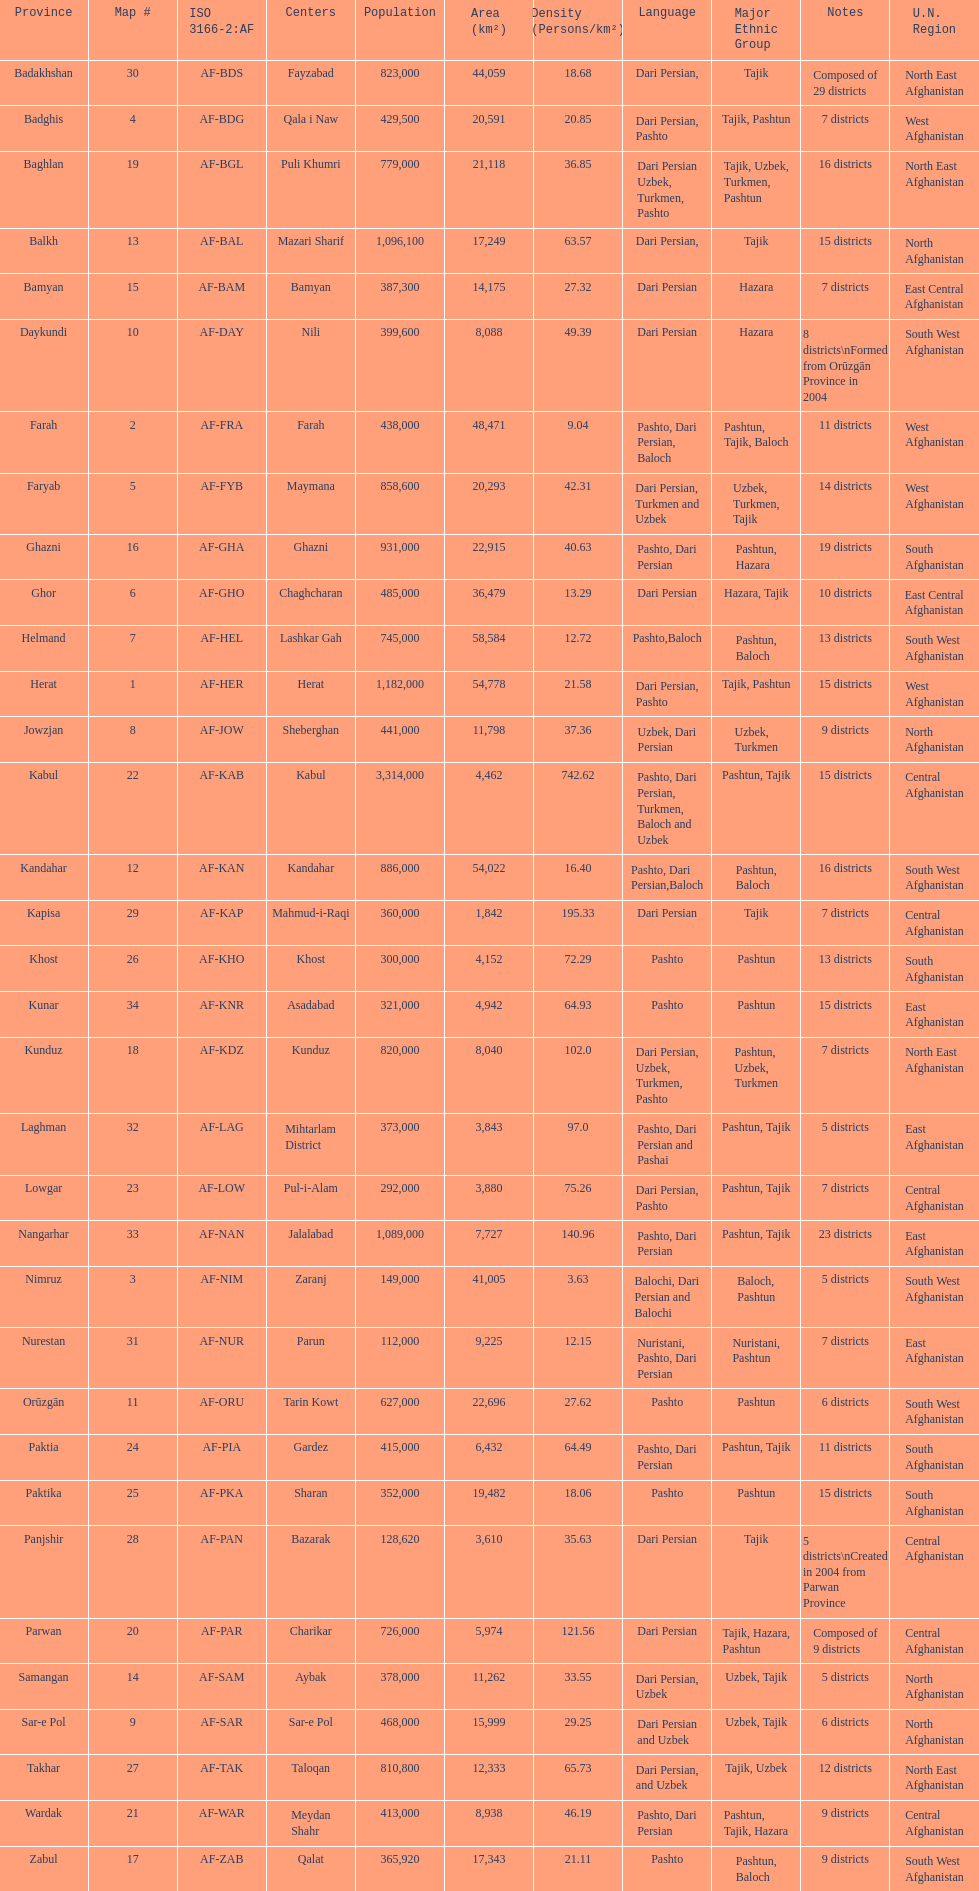Herat has a population of 1,182,000, can you list their languages Dari Persian, Pashto. I'm looking to parse the entire table for insights. Could you assist me with that? {'header': ['Province', 'Map #', 'ISO 3166-2:AF', 'Centers', 'Population', 'Area (km²)', 'Density (Persons/km²)', 'Language', 'Major Ethnic Group', 'Notes', 'U.N. Region'], 'rows': [['Badakhshan', '30', 'AF-BDS', 'Fayzabad', '823,000', '44,059', '18.68', 'Dari Persian,', 'Tajik', 'Composed of 29 districts', 'North East Afghanistan'], ['Badghis', '4', 'AF-BDG', 'Qala i Naw', '429,500', '20,591', '20.85', 'Dari Persian, Pashto', 'Tajik, Pashtun', '7 districts', 'West Afghanistan'], ['Baghlan', '19', 'AF-BGL', 'Puli Khumri', '779,000', '21,118', '36.85', 'Dari Persian Uzbek, Turkmen, Pashto', 'Tajik, Uzbek, Turkmen, Pashtun', '16 districts', 'North East Afghanistan'], ['Balkh', '13', 'AF-BAL', 'Mazari Sharif', '1,096,100', '17,249', '63.57', 'Dari Persian,', 'Tajik', '15 districts', 'North Afghanistan'], ['Bamyan', '15', 'AF-BAM', 'Bamyan', '387,300', '14,175', '27.32', 'Dari Persian', 'Hazara', '7 districts', 'East Central Afghanistan'], ['Daykundi', '10', 'AF-DAY', 'Nili', '399,600', '8,088', '49.39', 'Dari Persian', 'Hazara', '8 districts\\nFormed from Orūzgān Province in 2004', 'South West Afghanistan'], ['Farah', '2', 'AF-FRA', 'Farah', '438,000', '48,471', '9.04', 'Pashto, Dari Persian, Baloch', 'Pashtun, Tajik, Baloch', '11 districts', 'West Afghanistan'], ['Faryab', '5', 'AF-FYB', 'Maymana', '858,600', '20,293', '42.31', 'Dari Persian, Turkmen and Uzbek', 'Uzbek, Turkmen, Tajik', '14 districts', 'West Afghanistan'], ['Ghazni', '16', 'AF-GHA', 'Ghazni', '931,000', '22,915', '40.63', 'Pashto, Dari Persian', 'Pashtun, Hazara', '19 districts', 'South Afghanistan'], ['Ghor', '6', 'AF-GHO', 'Chaghcharan', '485,000', '36,479', '13.29', 'Dari Persian', 'Hazara, Tajik', '10 districts', 'East Central Afghanistan'], ['Helmand', '7', 'AF-HEL', 'Lashkar Gah', '745,000', '58,584', '12.72', 'Pashto,Baloch', 'Pashtun, Baloch', '13 districts', 'South West Afghanistan'], ['Herat', '1', 'AF-HER', 'Herat', '1,182,000', '54,778', '21.58', 'Dari Persian, Pashto', 'Tajik, Pashtun', '15 districts', 'West Afghanistan'], ['Jowzjan', '8', 'AF-JOW', 'Sheberghan', '441,000', '11,798', '37.36', 'Uzbek, Dari Persian', 'Uzbek, Turkmen', '9 districts', 'North Afghanistan'], ['Kabul', '22', 'AF-KAB', 'Kabul', '3,314,000', '4,462', '742.62', 'Pashto, Dari Persian, Turkmen, Baloch and Uzbek', 'Pashtun, Tajik', '15 districts', 'Central Afghanistan'], ['Kandahar', '12', 'AF-KAN', 'Kandahar', '886,000', '54,022', '16.40', 'Pashto, Dari Persian,Baloch', 'Pashtun, Baloch', '16 districts', 'South West Afghanistan'], ['Kapisa', '29', 'AF-KAP', 'Mahmud-i-Raqi', '360,000', '1,842', '195.33', 'Dari Persian', 'Tajik', '7 districts', 'Central Afghanistan'], ['Khost', '26', 'AF-KHO', 'Khost', '300,000', '4,152', '72.29', 'Pashto', 'Pashtun', '13 districts', 'South Afghanistan'], ['Kunar', '34', 'AF-KNR', 'Asadabad', '321,000', '4,942', '64.93', 'Pashto', 'Pashtun', '15 districts', 'East Afghanistan'], ['Kunduz', '18', 'AF-KDZ', 'Kunduz', '820,000', '8,040', '102.0', 'Dari Persian, Uzbek, Turkmen, Pashto', 'Pashtun, Uzbek, Turkmen', '7 districts', 'North East Afghanistan'], ['Laghman', '32', 'AF-LAG', 'Mihtarlam District', '373,000', '3,843', '97.0', 'Pashto, Dari Persian and Pashai', 'Pashtun, Tajik', '5 districts', 'East Afghanistan'], ['Lowgar', '23', 'AF-LOW', 'Pul-i-Alam', '292,000', '3,880', '75.26', 'Dari Persian, Pashto', 'Pashtun, Tajik', '7 districts', 'Central Afghanistan'], ['Nangarhar', '33', 'AF-NAN', 'Jalalabad', '1,089,000', '7,727', '140.96', 'Pashto, Dari Persian', 'Pashtun, Tajik', '23 districts', 'East Afghanistan'], ['Nimruz', '3', 'AF-NIM', 'Zaranj', '149,000', '41,005', '3.63', 'Balochi, Dari Persian and Balochi', 'Baloch, Pashtun', '5 districts', 'South West Afghanistan'], ['Nurestan', '31', 'AF-NUR', 'Parun', '112,000', '9,225', '12.15', 'Nuristani, Pashto, Dari Persian', 'Nuristani, Pashtun', '7 districts', 'East Afghanistan'], ['Orūzgān', '11', 'AF-ORU', 'Tarin Kowt', '627,000', '22,696', '27.62', 'Pashto', 'Pashtun', '6 districts', 'South West Afghanistan'], ['Paktia', '24', 'AF-PIA', 'Gardez', '415,000', '6,432', '64.49', 'Pashto, Dari Persian', 'Pashtun, Tajik', '11 districts', 'South Afghanistan'], ['Paktika', '25', 'AF-PKA', 'Sharan', '352,000', '19,482', '18.06', 'Pashto', 'Pashtun', '15 districts', 'South Afghanistan'], ['Panjshir', '28', 'AF-PAN', 'Bazarak', '128,620', '3,610', '35.63', 'Dari Persian', 'Tajik', '5 districts\\nCreated in 2004 from Parwan Province', 'Central Afghanistan'], ['Parwan', '20', 'AF-PAR', 'Charikar', '726,000', '5,974', '121.56', 'Dari Persian', 'Tajik, Hazara, Pashtun', 'Composed of 9 districts', 'Central Afghanistan'], ['Samangan', '14', 'AF-SAM', 'Aybak', '378,000', '11,262', '33.55', 'Dari Persian, Uzbek', 'Uzbek, Tajik', '5 districts', 'North Afghanistan'], ['Sar-e Pol', '9', 'AF-SAR', 'Sar-e Pol', '468,000', '15,999', '29.25', 'Dari Persian and Uzbek', 'Uzbek, Tajik', '6 districts', 'North Afghanistan'], ['Takhar', '27', 'AF-TAK', 'Taloqan', '810,800', '12,333', '65.73', 'Dari Persian, and Uzbek', 'Tajik, Uzbek', '12 districts', 'North East Afghanistan'], ['Wardak', '21', 'AF-WAR', 'Meydan Shahr', '413,000', '8,938', '46.19', 'Pashto, Dari Persian', 'Pashtun, Tajik, Hazara', '9 districts', 'Central Afghanistan'], ['Zabul', '17', 'AF-ZAB', 'Qalat', '365,920', '17,343', '21.11', 'Pashto', 'Pashtun, Baloch', '9 districts', 'South West Afghanistan']]} 